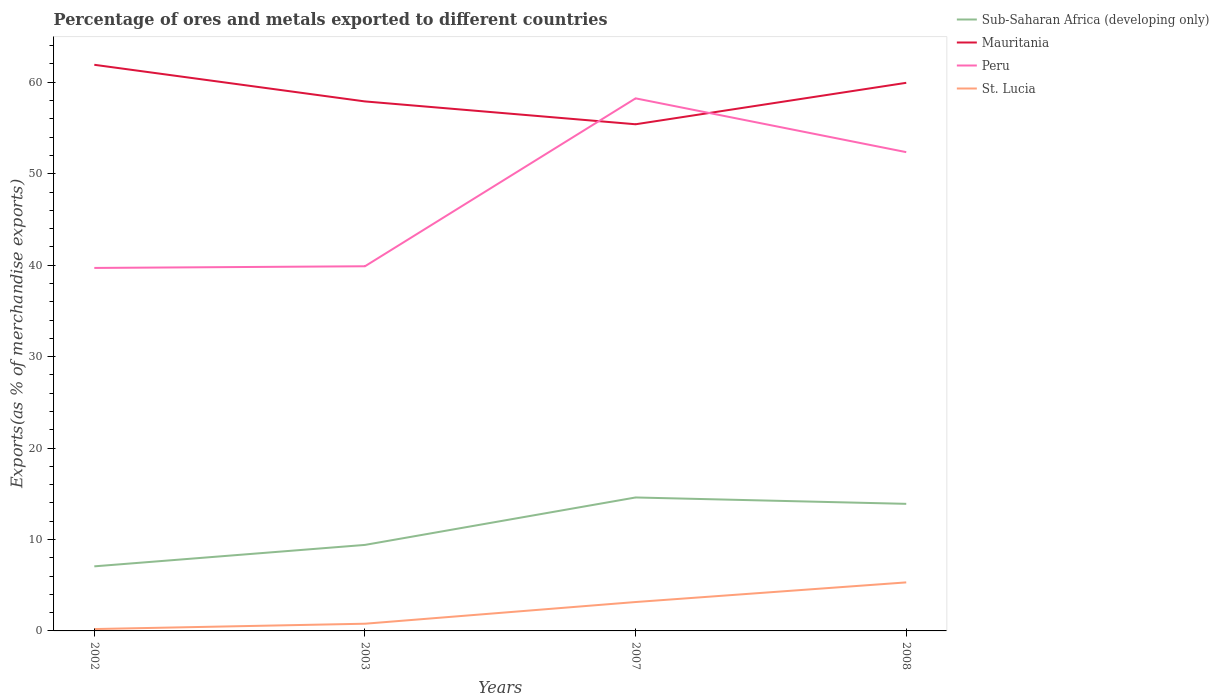How many different coloured lines are there?
Make the answer very short. 4. Across all years, what is the maximum percentage of exports to different countries in St. Lucia?
Offer a terse response. 0.2. What is the total percentage of exports to different countries in Peru in the graph?
Your response must be concise. -18.55. What is the difference between the highest and the second highest percentage of exports to different countries in Peru?
Your response must be concise. 18.55. What is the difference between the highest and the lowest percentage of exports to different countries in Mauritania?
Your answer should be compact. 2. Is the percentage of exports to different countries in Mauritania strictly greater than the percentage of exports to different countries in Sub-Saharan Africa (developing only) over the years?
Your answer should be compact. No. What is the difference between two consecutive major ticks on the Y-axis?
Make the answer very short. 10. Are the values on the major ticks of Y-axis written in scientific E-notation?
Your response must be concise. No. Does the graph contain grids?
Your answer should be very brief. No. Where does the legend appear in the graph?
Your answer should be compact. Top right. How many legend labels are there?
Your response must be concise. 4. How are the legend labels stacked?
Make the answer very short. Vertical. What is the title of the graph?
Keep it short and to the point. Percentage of ores and metals exported to different countries. Does "Poland" appear as one of the legend labels in the graph?
Provide a succinct answer. No. What is the label or title of the Y-axis?
Your response must be concise. Exports(as % of merchandise exports). What is the Exports(as % of merchandise exports) of Sub-Saharan Africa (developing only) in 2002?
Your response must be concise. 7.06. What is the Exports(as % of merchandise exports) of Mauritania in 2002?
Your answer should be compact. 61.91. What is the Exports(as % of merchandise exports) of Peru in 2002?
Offer a terse response. 39.69. What is the Exports(as % of merchandise exports) of St. Lucia in 2002?
Keep it short and to the point. 0.2. What is the Exports(as % of merchandise exports) in Sub-Saharan Africa (developing only) in 2003?
Give a very brief answer. 9.41. What is the Exports(as % of merchandise exports) in Mauritania in 2003?
Provide a short and direct response. 57.91. What is the Exports(as % of merchandise exports) in Peru in 2003?
Provide a short and direct response. 39.88. What is the Exports(as % of merchandise exports) in St. Lucia in 2003?
Offer a very short reply. 0.79. What is the Exports(as % of merchandise exports) of Sub-Saharan Africa (developing only) in 2007?
Keep it short and to the point. 14.59. What is the Exports(as % of merchandise exports) of Mauritania in 2007?
Provide a succinct answer. 55.41. What is the Exports(as % of merchandise exports) of Peru in 2007?
Your answer should be compact. 58.24. What is the Exports(as % of merchandise exports) in St. Lucia in 2007?
Provide a succinct answer. 3.16. What is the Exports(as % of merchandise exports) in Sub-Saharan Africa (developing only) in 2008?
Keep it short and to the point. 13.9. What is the Exports(as % of merchandise exports) in Mauritania in 2008?
Your answer should be very brief. 59.94. What is the Exports(as % of merchandise exports) in Peru in 2008?
Your answer should be very brief. 52.36. What is the Exports(as % of merchandise exports) of St. Lucia in 2008?
Provide a succinct answer. 5.31. Across all years, what is the maximum Exports(as % of merchandise exports) of Sub-Saharan Africa (developing only)?
Offer a terse response. 14.59. Across all years, what is the maximum Exports(as % of merchandise exports) of Mauritania?
Provide a short and direct response. 61.91. Across all years, what is the maximum Exports(as % of merchandise exports) of Peru?
Make the answer very short. 58.24. Across all years, what is the maximum Exports(as % of merchandise exports) of St. Lucia?
Make the answer very short. 5.31. Across all years, what is the minimum Exports(as % of merchandise exports) of Sub-Saharan Africa (developing only)?
Make the answer very short. 7.06. Across all years, what is the minimum Exports(as % of merchandise exports) of Mauritania?
Your response must be concise. 55.41. Across all years, what is the minimum Exports(as % of merchandise exports) in Peru?
Offer a very short reply. 39.69. Across all years, what is the minimum Exports(as % of merchandise exports) of St. Lucia?
Offer a terse response. 0.2. What is the total Exports(as % of merchandise exports) in Sub-Saharan Africa (developing only) in the graph?
Your answer should be very brief. 44.96. What is the total Exports(as % of merchandise exports) of Mauritania in the graph?
Provide a succinct answer. 235.17. What is the total Exports(as % of merchandise exports) in Peru in the graph?
Ensure brevity in your answer.  190.17. What is the total Exports(as % of merchandise exports) in St. Lucia in the graph?
Keep it short and to the point. 9.46. What is the difference between the Exports(as % of merchandise exports) of Sub-Saharan Africa (developing only) in 2002 and that in 2003?
Ensure brevity in your answer.  -2.34. What is the difference between the Exports(as % of merchandise exports) in Mauritania in 2002 and that in 2003?
Provide a succinct answer. 4.01. What is the difference between the Exports(as % of merchandise exports) in Peru in 2002 and that in 2003?
Provide a short and direct response. -0.18. What is the difference between the Exports(as % of merchandise exports) in St. Lucia in 2002 and that in 2003?
Ensure brevity in your answer.  -0.58. What is the difference between the Exports(as % of merchandise exports) of Sub-Saharan Africa (developing only) in 2002 and that in 2007?
Keep it short and to the point. -7.53. What is the difference between the Exports(as % of merchandise exports) of Mauritania in 2002 and that in 2007?
Ensure brevity in your answer.  6.5. What is the difference between the Exports(as % of merchandise exports) of Peru in 2002 and that in 2007?
Keep it short and to the point. -18.55. What is the difference between the Exports(as % of merchandise exports) in St. Lucia in 2002 and that in 2007?
Offer a very short reply. -2.96. What is the difference between the Exports(as % of merchandise exports) in Sub-Saharan Africa (developing only) in 2002 and that in 2008?
Your response must be concise. -6.83. What is the difference between the Exports(as % of merchandise exports) in Mauritania in 2002 and that in 2008?
Provide a short and direct response. 1.97. What is the difference between the Exports(as % of merchandise exports) of Peru in 2002 and that in 2008?
Give a very brief answer. -12.66. What is the difference between the Exports(as % of merchandise exports) of St. Lucia in 2002 and that in 2008?
Offer a very short reply. -5.1. What is the difference between the Exports(as % of merchandise exports) of Sub-Saharan Africa (developing only) in 2003 and that in 2007?
Provide a short and direct response. -5.19. What is the difference between the Exports(as % of merchandise exports) in Mauritania in 2003 and that in 2007?
Your answer should be compact. 2.5. What is the difference between the Exports(as % of merchandise exports) in Peru in 2003 and that in 2007?
Give a very brief answer. -18.36. What is the difference between the Exports(as % of merchandise exports) of St. Lucia in 2003 and that in 2007?
Provide a succinct answer. -2.37. What is the difference between the Exports(as % of merchandise exports) of Sub-Saharan Africa (developing only) in 2003 and that in 2008?
Provide a short and direct response. -4.49. What is the difference between the Exports(as % of merchandise exports) in Mauritania in 2003 and that in 2008?
Make the answer very short. -2.04. What is the difference between the Exports(as % of merchandise exports) of Peru in 2003 and that in 2008?
Your response must be concise. -12.48. What is the difference between the Exports(as % of merchandise exports) in St. Lucia in 2003 and that in 2008?
Keep it short and to the point. -4.52. What is the difference between the Exports(as % of merchandise exports) of Sub-Saharan Africa (developing only) in 2007 and that in 2008?
Give a very brief answer. 0.7. What is the difference between the Exports(as % of merchandise exports) of Mauritania in 2007 and that in 2008?
Make the answer very short. -4.53. What is the difference between the Exports(as % of merchandise exports) of Peru in 2007 and that in 2008?
Offer a terse response. 5.88. What is the difference between the Exports(as % of merchandise exports) of St. Lucia in 2007 and that in 2008?
Offer a very short reply. -2.15. What is the difference between the Exports(as % of merchandise exports) in Sub-Saharan Africa (developing only) in 2002 and the Exports(as % of merchandise exports) in Mauritania in 2003?
Give a very brief answer. -50.84. What is the difference between the Exports(as % of merchandise exports) of Sub-Saharan Africa (developing only) in 2002 and the Exports(as % of merchandise exports) of Peru in 2003?
Provide a succinct answer. -32.82. What is the difference between the Exports(as % of merchandise exports) in Sub-Saharan Africa (developing only) in 2002 and the Exports(as % of merchandise exports) in St. Lucia in 2003?
Offer a very short reply. 6.28. What is the difference between the Exports(as % of merchandise exports) in Mauritania in 2002 and the Exports(as % of merchandise exports) in Peru in 2003?
Offer a very short reply. 22.03. What is the difference between the Exports(as % of merchandise exports) of Mauritania in 2002 and the Exports(as % of merchandise exports) of St. Lucia in 2003?
Offer a terse response. 61.12. What is the difference between the Exports(as % of merchandise exports) in Peru in 2002 and the Exports(as % of merchandise exports) in St. Lucia in 2003?
Keep it short and to the point. 38.91. What is the difference between the Exports(as % of merchandise exports) of Sub-Saharan Africa (developing only) in 2002 and the Exports(as % of merchandise exports) of Mauritania in 2007?
Your answer should be compact. -48.35. What is the difference between the Exports(as % of merchandise exports) of Sub-Saharan Africa (developing only) in 2002 and the Exports(as % of merchandise exports) of Peru in 2007?
Give a very brief answer. -51.18. What is the difference between the Exports(as % of merchandise exports) in Sub-Saharan Africa (developing only) in 2002 and the Exports(as % of merchandise exports) in St. Lucia in 2007?
Make the answer very short. 3.9. What is the difference between the Exports(as % of merchandise exports) of Mauritania in 2002 and the Exports(as % of merchandise exports) of Peru in 2007?
Keep it short and to the point. 3.67. What is the difference between the Exports(as % of merchandise exports) of Mauritania in 2002 and the Exports(as % of merchandise exports) of St. Lucia in 2007?
Your response must be concise. 58.75. What is the difference between the Exports(as % of merchandise exports) in Peru in 2002 and the Exports(as % of merchandise exports) in St. Lucia in 2007?
Make the answer very short. 36.53. What is the difference between the Exports(as % of merchandise exports) of Sub-Saharan Africa (developing only) in 2002 and the Exports(as % of merchandise exports) of Mauritania in 2008?
Your response must be concise. -52.88. What is the difference between the Exports(as % of merchandise exports) in Sub-Saharan Africa (developing only) in 2002 and the Exports(as % of merchandise exports) in Peru in 2008?
Ensure brevity in your answer.  -45.3. What is the difference between the Exports(as % of merchandise exports) in Sub-Saharan Africa (developing only) in 2002 and the Exports(as % of merchandise exports) in St. Lucia in 2008?
Make the answer very short. 1.76. What is the difference between the Exports(as % of merchandise exports) of Mauritania in 2002 and the Exports(as % of merchandise exports) of Peru in 2008?
Keep it short and to the point. 9.55. What is the difference between the Exports(as % of merchandise exports) of Mauritania in 2002 and the Exports(as % of merchandise exports) of St. Lucia in 2008?
Your response must be concise. 56.61. What is the difference between the Exports(as % of merchandise exports) in Peru in 2002 and the Exports(as % of merchandise exports) in St. Lucia in 2008?
Provide a succinct answer. 34.39. What is the difference between the Exports(as % of merchandise exports) of Sub-Saharan Africa (developing only) in 2003 and the Exports(as % of merchandise exports) of Mauritania in 2007?
Your response must be concise. -46. What is the difference between the Exports(as % of merchandise exports) of Sub-Saharan Africa (developing only) in 2003 and the Exports(as % of merchandise exports) of Peru in 2007?
Your response must be concise. -48.83. What is the difference between the Exports(as % of merchandise exports) of Sub-Saharan Africa (developing only) in 2003 and the Exports(as % of merchandise exports) of St. Lucia in 2007?
Keep it short and to the point. 6.25. What is the difference between the Exports(as % of merchandise exports) in Mauritania in 2003 and the Exports(as % of merchandise exports) in Peru in 2007?
Offer a terse response. -0.34. What is the difference between the Exports(as % of merchandise exports) in Mauritania in 2003 and the Exports(as % of merchandise exports) in St. Lucia in 2007?
Your answer should be compact. 54.74. What is the difference between the Exports(as % of merchandise exports) of Peru in 2003 and the Exports(as % of merchandise exports) of St. Lucia in 2007?
Provide a short and direct response. 36.72. What is the difference between the Exports(as % of merchandise exports) in Sub-Saharan Africa (developing only) in 2003 and the Exports(as % of merchandise exports) in Mauritania in 2008?
Make the answer very short. -50.53. What is the difference between the Exports(as % of merchandise exports) in Sub-Saharan Africa (developing only) in 2003 and the Exports(as % of merchandise exports) in Peru in 2008?
Provide a succinct answer. -42.95. What is the difference between the Exports(as % of merchandise exports) of Sub-Saharan Africa (developing only) in 2003 and the Exports(as % of merchandise exports) of St. Lucia in 2008?
Provide a short and direct response. 4.1. What is the difference between the Exports(as % of merchandise exports) in Mauritania in 2003 and the Exports(as % of merchandise exports) in Peru in 2008?
Give a very brief answer. 5.55. What is the difference between the Exports(as % of merchandise exports) in Mauritania in 2003 and the Exports(as % of merchandise exports) in St. Lucia in 2008?
Give a very brief answer. 52.6. What is the difference between the Exports(as % of merchandise exports) in Peru in 2003 and the Exports(as % of merchandise exports) in St. Lucia in 2008?
Your answer should be compact. 34.57. What is the difference between the Exports(as % of merchandise exports) of Sub-Saharan Africa (developing only) in 2007 and the Exports(as % of merchandise exports) of Mauritania in 2008?
Ensure brevity in your answer.  -45.35. What is the difference between the Exports(as % of merchandise exports) in Sub-Saharan Africa (developing only) in 2007 and the Exports(as % of merchandise exports) in Peru in 2008?
Ensure brevity in your answer.  -37.77. What is the difference between the Exports(as % of merchandise exports) in Sub-Saharan Africa (developing only) in 2007 and the Exports(as % of merchandise exports) in St. Lucia in 2008?
Your answer should be compact. 9.29. What is the difference between the Exports(as % of merchandise exports) of Mauritania in 2007 and the Exports(as % of merchandise exports) of Peru in 2008?
Your response must be concise. 3.05. What is the difference between the Exports(as % of merchandise exports) of Mauritania in 2007 and the Exports(as % of merchandise exports) of St. Lucia in 2008?
Ensure brevity in your answer.  50.1. What is the difference between the Exports(as % of merchandise exports) of Peru in 2007 and the Exports(as % of merchandise exports) of St. Lucia in 2008?
Provide a short and direct response. 52.93. What is the average Exports(as % of merchandise exports) in Sub-Saharan Africa (developing only) per year?
Offer a terse response. 11.24. What is the average Exports(as % of merchandise exports) in Mauritania per year?
Your answer should be compact. 58.79. What is the average Exports(as % of merchandise exports) in Peru per year?
Offer a very short reply. 47.54. What is the average Exports(as % of merchandise exports) in St. Lucia per year?
Your answer should be very brief. 2.36. In the year 2002, what is the difference between the Exports(as % of merchandise exports) in Sub-Saharan Africa (developing only) and Exports(as % of merchandise exports) in Mauritania?
Offer a very short reply. -54.85. In the year 2002, what is the difference between the Exports(as % of merchandise exports) of Sub-Saharan Africa (developing only) and Exports(as % of merchandise exports) of Peru?
Keep it short and to the point. -32.63. In the year 2002, what is the difference between the Exports(as % of merchandise exports) in Sub-Saharan Africa (developing only) and Exports(as % of merchandise exports) in St. Lucia?
Your answer should be compact. 6.86. In the year 2002, what is the difference between the Exports(as % of merchandise exports) of Mauritania and Exports(as % of merchandise exports) of Peru?
Give a very brief answer. 22.22. In the year 2002, what is the difference between the Exports(as % of merchandise exports) of Mauritania and Exports(as % of merchandise exports) of St. Lucia?
Your response must be concise. 61.71. In the year 2002, what is the difference between the Exports(as % of merchandise exports) of Peru and Exports(as % of merchandise exports) of St. Lucia?
Provide a succinct answer. 39.49. In the year 2003, what is the difference between the Exports(as % of merchandise exports) of Sub-Saharan Africa (developing only) and Exports(as % of merchandise exports) of Mauritania?
Give a very brief answer. -48.5. In the year 2003, what is the difference between the Exports(as % of merchandise exports) in Sub-Saharan Africa (developing only) and Exports(as % of merchandise exports) in Peru?
Your answer should be very brief. -30.47. In the year 2003, what is the difference between the Exports(as % of merchandise exports) in Sub-Saharan Africa (developing only) and Exports(as % of merchandise exports) in St. Lucia?
Make the answer very short. 8.62. In the year 2003, what is the difference between the Exports(as % of merchandise exports) in Mauritania and Exports(as % of merchandise exports) in Peru?
Your answer should be compact. 18.03. In the year 2003, what is the difference between the Exports(as % of merchandise exports) in Mauritania and Exports(as % of merchandise exports) in St. Lucia?
Offer a terse response. 57.12. In the year 2003, what is the difference between the Exports(as % of merchandise exports) in Peru and Exports(as % of merchandise exports) in St. Lucia?
Your answer should be compact. 39.09. In the year 2007, what is the difference between the Exports(as % of merchandise exports) of Sub-Saharan Africa (developing only) and Exports(as % of merchandise exports) of Mauritania?
Your response must be concise. -40.81. In the year 2007, what is the difference between the Exports(as % of merchandise exports) of Sub-Saharan Africa (developing only) and Exports(as % of merchandise exports) of Peru?
Keep it short and to the point. -43.65. In the year 2007, what is the difference between the Exports(as % of merchandise exports) of Sub-Saharan Africa (developing only) and Exports(as % of merchandise exports) of St. Lucia?
Make the answer very short. 11.43. In the year 2007, what is the difference between the Exports(as % of merchandise exports) of Mauritania and Exports(as % of merchandise exports) of Peru?
Offer a very short reply. -2.83. In the year 2007, what is the difference between the Exports(as % of merchandise exports) of Mauritania and Exports(as % of merchandise exports) of St. Lucia?
Provide a short and direct response. 52.25. In the year 2007, what is the difference between the Exports(as % of merchandise exports) of Peru and Exports(as % of merchandise exports) of St. Lucia?
Ensure brevity in your answer.  55.08. In the year 2008, what is the difference between the Exports(as % of merchandise exports) in Sub-Saharan Africa (developing only) and Exports(as % of merchandise exports) in Mauritania?
Your answer should be compact. -46.04. In the year 2008, what is the difference between the Exports(as % of merchandise exports) of Sub-Saharan Africa (developing only) and Exports(as % of merchandise exports) of Peru?
Your response must be concise. -38.46. In the year 2008, what is the difference between the Exports(as % of merchandise exports) of Sub-Saharan Africa (developing only) and Exports(as % of merchandise exports) of St. Lucia?
Your response must be concise. 8.59. In the year 2008, what is the difference between the Exports(as % of merchandise exports) of Mauritania and Exports(as % of merchandise exports) of Peru?
Keep it short and to the point. 7.58. In the year 2008, what is the difference between the Exports(as % of merchandise exports) in Mauritania and Exports(as % of merchandise exports) in St. Lucia?
Keep it short and to the point. 54.63. In the year 2008, what is the difference between the Exports(as % of merchandise exports) of Peru and Exports(as % of merchandise exports) of St. Lucia?
Your answer should be very brief. 47.05. What is the ratio of the Exports(as % of merchandise exports) of Sub-Saharan Africa (developing only) in 2002 to that in 2003?
Ensure brevity in your answer.  0.75. What is the ratio of the Exports(as % of merchandise exports) of Mauritania in 2002 to that in 2003?
Keep it short and to the point. 1.07. What is the ratio of the Exports(as % of merchandise exports) of Peru in 2002 to that in 2003?
Ensure brevity in your answer.  1. What is the ratio of the Exports(as % of merchandise exports) in St. Lucia in 2002 to that in 2003?
Ensure brevity in your answer.  0.26. What is the ratio of the Exports(as % of merchandise exports) of Sub-Saharan Africa (developing only) in 2002 to that in 2007?
Give a very brief answer. 0.48. What is the ratio of the Exports(as % of merchandise exports) in Mauritania in 2002 to that in 2007?
Provide a succinct answer. 1.12. What is the ratio of the Exports(as % of merchandise exports) of Peru in 2002 to that in 2007?
Ensure brevity in your answer.  0.68. What is the ratio of the Exports(as % of merchandise exports) of St. Lucia in 2002 to that in 2007?
Provide a short and direct response. 0.06. What is the ratio of the Exports(as % of merchandise exports) in Sub-Saharan Africa (developing only) in 2002 to that in 2008?
Keep it short and to the point. 0.51. What is the ratio of the Exports(as % of merchandise exports) in Mauritania in 2002 to that in 2008?
Give a very brief answer. 1.03. What is the ratio of the Exports(as % of merchandise exports) in Peru in 2002 to that in 2008?
Provide a short and direct response. 0.76. What is the ratio of the Exports(as % of merchandise exports) in St. Lucia in 2002 to that in 2008?
Your response must be concise. 0.04. What is the ratio of the Exports(as % of merchandise exports) in Sub-Saharan Africa (developing only) in 2003 to that in 2007?
Your answer should be compact. 0.64. What is the ratio of the Exports(as % of merchandise exports) of Mauritania in 2003 to that in 2007?
Your response must be concise. 1.05. What is the ratio of the Exports(as % of merchandise exports) of Peru in 2003 to that in 2007?
Ensure brevity in your answer.  0.68. What is the ratio of the Exports(as % of merchandise exports) in St. Lucia in 2003 to that in 2007?
Ensure brevity in your answer.  0.25. What is the ratio of the Exports(as % of merchandise exports) of Sub-Saharan Africa (developing only) in 2003 to that in 2008?
Your answer should be very brief. 0.68. What is the ratio of the Exports(as % of merchandise exports) of Mauritania in 2003 to that in 2008?
Your response must be concise. 0.97. What is the ratio of the Exports(as % of merchandise exports) in Peru in 2003 to that in 2008?
Your answer should be compact. 0.76. What is the ratio of the Exports(as % of merchandise exports) of St. Lucia in 2003 to that in 2008?
Offer a terse response. 0.15. What is the ratio of the Exports(as % of merchandise exports) of Sub-Saharan Africa (developing only) in 2007 to that in 2008?
Give a very brief answer. 1.05. What is the ratio of the Exports(as % of merchandise exports) in Mauritania in 2007 to that in 2008?
Make the answer very short. 0.92. What is the ratio of the Exports(as % of merchandise exports) of Peru in 2007 to that in 2008?
Offer a terse response. 1.11. What is the ratio of the Exports(as % of merchandise exports) of St. Lucia in 2007 to that in 2008?
Provide a succinct answer. 0.6. What is the difference between the highest and the second highest Exports(as % of merchandise exports) in Sub-Saharan Africa (developing only)?
Your response must be concise. 0.7. What is the difference between the highest and the second highest Exports(as % of merchandise exports) in Mauritania?
Give a very brief answer. 1.97. What is the difference between the highest and the second highest Exports(as % of merchandise exports) of Peru?
Give a very brief answer. 5.88. What is the difference between the highest and the second highest Exports(as % of merchandise exports) in St. Lucia?
Offer a terse response. 2.15. What is the difference between the highest and the lowest Exports(as % of merchandise exports) in Sub-Saharan Africa (developing only)?
Provide a short and direct response. 7.53. What is the difference between the highest and the lowest Exports(as % of merchandise exports) of Mauritania?
Provide a short and direct response. 6.5. What is the difference between the highest and the lowest Exports(as % of merchandise exports) of Peru?
Make the answer very short. 18.55. What is the difference between the highest and the lowest Exports(as % of merchandise exports) of St. Lucia?
Give a very brief answer. 5.1. 